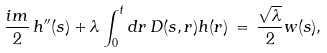<formula> <loc_0><loc_0><loc_500><loc_500>\frac { i m } { 2 } \, h ^ { \prime \prime } ( s ) + \lambda \int _ { 0 } ^ { t } d r \, D ( s , r ) h ( r ) \, = \, \frac { \sqrt { \lambda } } { 2 } w ( s ) ,</formula> 